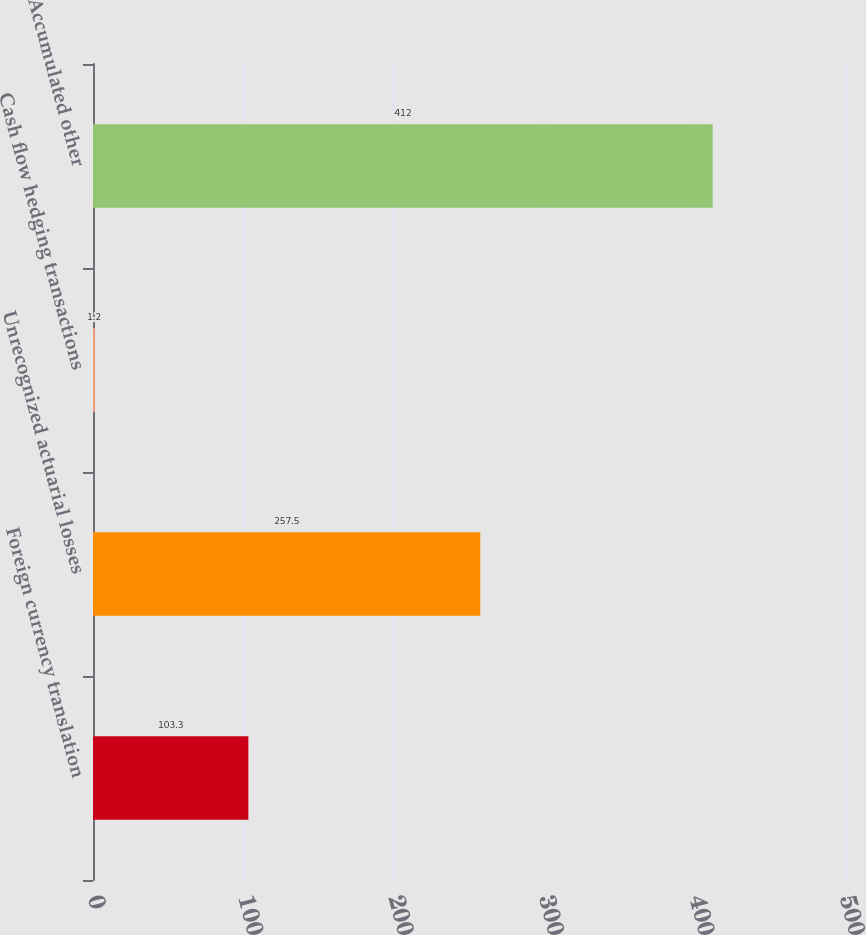Convert chart to OTSL. <chart><loc_0><loc_0><loc_500><loc_500><bar_chart><fcel>Foreign currency translation<fcel>Unrecognized actuarial losses<fcel>Cash flow hedging transactions<fcel>Accumulated other<nl><fcel>103.3<fcel>257.5<fcel>1.2<fcel>412<nl></chart> 